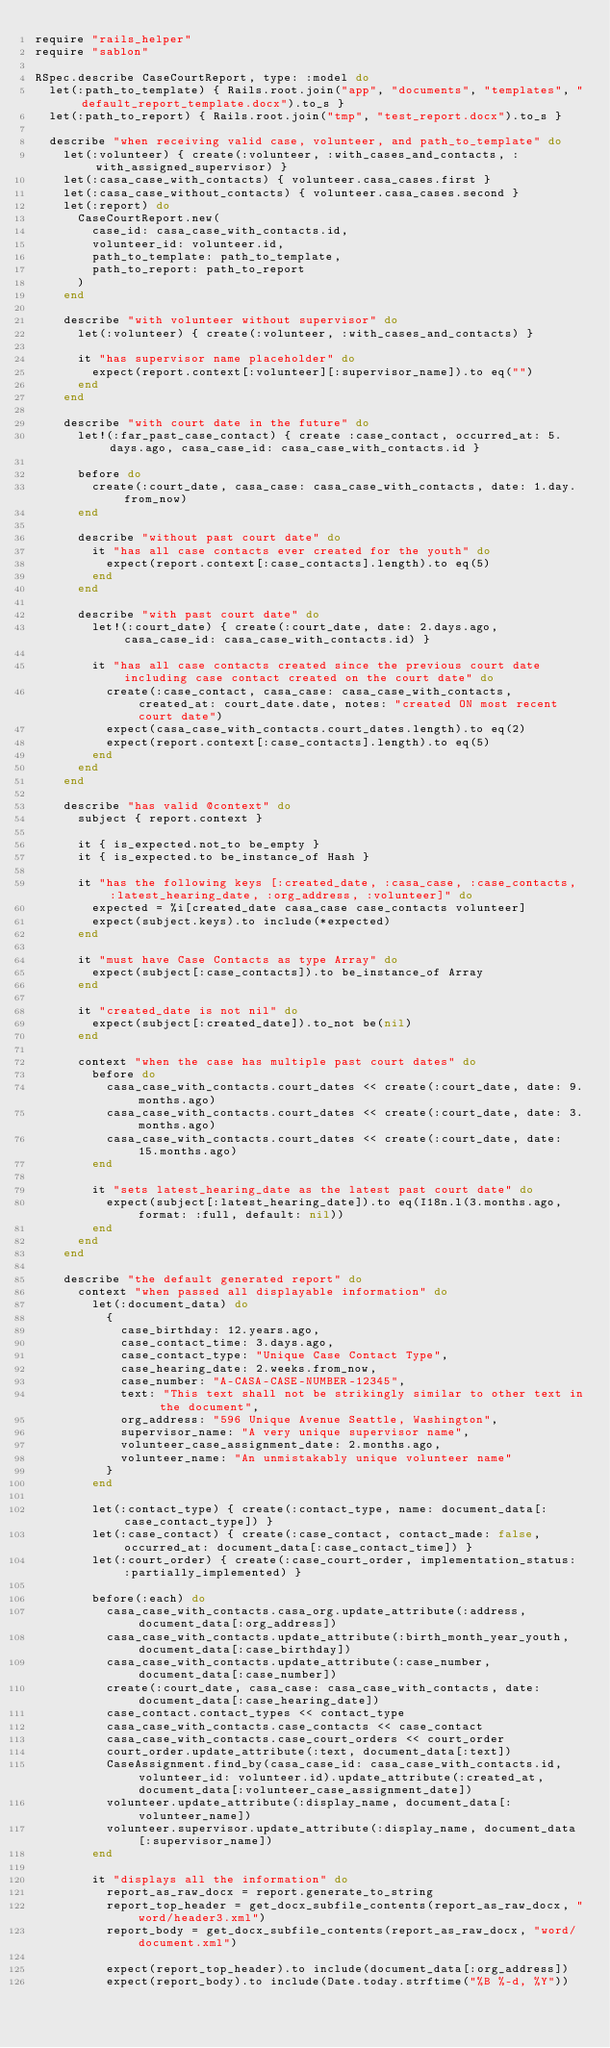Convert code to text. <code><loc_0><loc_0><loc_500><loc_500><_Ruby_>require "rails_helper"
require "sablon"

RSpec.describe CaseCourtReport, type: :model do
  let(:path_to_template) { Rails.root.join("app", "documents", "templates", "default_report_template.docx").to_s }
  let(:path_to_report) { Rails.root.join("tmp", "test_report.docx").to_s }

  describe "when receiving valid case, volunteer, and path_to_template" do
    let(:volunteer) { create(:volunteer, :with_cases_and_contacts, :with_assigned_supervisor) }
    let(:casa_case_with_contacts) { volunteer.casa_cases.first }
    let(:casa_case_without_contacts) { volunteer.casa_cases.second }
    let(:report) do
      CaseCourtReport.new(
        case_id: casa_case_with_contacts.id,
        volunteer_id: volunteer.id,
        path_to_template: path_to_template,
        path_to_report: path_to_report
      )
    end

    describe "with volunteer without supervisor" do
      let(:volunteer) { create(:volunteer, :with_cases_and_contacts) }

      it "has supervisor name placeholder" do
        expect(report.context[:volunteer][:supervisor_name]).to eq("")
      end
    end

    describe "with court date in the future" do
      let!(:far_past_case_contact) { create :case_contact, occurred_at: 5.days.ago, casa_case_id: casa_case_with_contacts.id }

      before do
        create(:court_date, casa_case: casa_case_with_contacts, date: 1.day.from_now)
      end

      describe "without past court date" do
        it "has all case contacts ever created for the youth" do
          expect(report.context[:case_contacts].length).to eq(5)
        end
      end

      describe "with past court date" do
        let!(:court_date) { create(:court_date, date: 2.days.ago, casa_case_id: casa_case_with_contacts.id) }

        it "has all case contacts created since the previous court date including case contact created on the court date" do
          create(:case_contact, casa_case: casa_case_with_contacts, created_at: court_date.date, notes: "created ON most recent court date")
          expect(casa_case_with_contacts.court_dates.length).to eq(2)
          expect(report.context[:case_contacts].length).to eq(5)
        end
      end
    end

    describe "has valid @context" do
      subject { report.context }

      it { is_expected.not_to be_empty }
      it { is_expected.to be_instance_of Hash }

      it "has the following keys [:created_date, :casa_case, :case_contacts, :latest_hearing_date, :org_address, :volunteer]" do
        expected = %i[created_date casa_case case_contacts volunteer]
        expect(subject.keys).to include(*expected)
      end

      it "must have Case Contacts as type Array" do
        expect(subject[:case_contacts]).to be_instance_of Array
      end

      it "created_date is not nil" do
        expect(subject[:created_date]).to_not be(nil)
      end

      context "when the case has multiple past court dates" do
        before do
          casa_case_with_contacts.court_dates << create(:court_date, date: 9.months.ago)
          casa_case_with_contacts.court_dates << create(:court_date, date: 3.months.ago)
          casa_case_with_contacts.court_dates << create(:court_date, date: 15.months.ago)
        end

        it "sets latest_hearing_date as the latest past court date" do
          expect(subject[:latest_hearing_date]).to eq(I18n.l(3.months.ago, format: :full, default: nil))
        end
      end
    end

    describe "the default generated report" do
      context "when passed all displayable information" do
        let(:document_data) do
          {
            case_birthday: 12.years.ago,
            case_contact_time: 3.days.ago,
            case_contact_type: "Unique Case Contact Type",
            case_hearing_date: 2.weeks.from_now,
            case_number: "A-CASA-CASE-NUMBER-12345",
            text: "This text shall not be strikingly similar to other text in the document",
            org_address: "596 Unique Avenue Seattle, Washington",
            supervisor_name: "A very unique supervisor name",
            volunteer_case_assignment_date: 2.months.ago,
            volunteer_name: "An unmistakably unique volunteer name"
          }
        end

        let(:contact_type) { create(:contact_type, name: document_data[:case_contact_type]) }
        let(:case_contact) { create(:case_contact, contact_made: false, occurred_at: document_data[:case_contact_time]) }
        let(:court_order) { create(:case_court_order, implementation_status: :partially_implemented) }

        before(:each) do
          casa_case_with_contacts.casa_org.update_attribute(:address, document_data[:org_address])
          casa_case_with_contacts.update_attribute(:birth_month_year_youth, document_data[:case_birthday])
          casa_case_with_contacts.update_attribute(:case_number, document_data[:case_number])
          create(:court_date, casa_case: casa_case_with_contacts, date: document_data[:case_hearing_date])
          case_contact.contact_types << contact_type
          casa_case_with_contacts.case_contacts << case_contact
          casa_case_with_contacts.case_court_orders << court_order
          court_order.update_attribute(:text, document_data[:text])
          CaseAssignment.find_by(casa_case_id: casa_case_with_contacts.id, volunteer_id: volunteer.id).update_attribute(:created_at, document_data[:volunteer_case_assignment_date])
          volunteer.update_attribute(:display_name, document_data[:volunteer_name])
          volunteer.supervisor.update_attribute(:display_name, document_data[:supervisor_name])
        end

        it "displays all the information" do
          report_as_raw_docx = report.generate_to_string
          report_top_header = get_docx_subfile_contents(report_as_raw_docx, "word/header3.xml")
          report_body = get_docx_subfile_contents(report_as_raw_docx, "word/document.xml")

          expect(report_top_header).to include(document_data[:org_address])
          expect(report_body).to include(Date.today.strftime("%B %-d, %Y"))</code> 